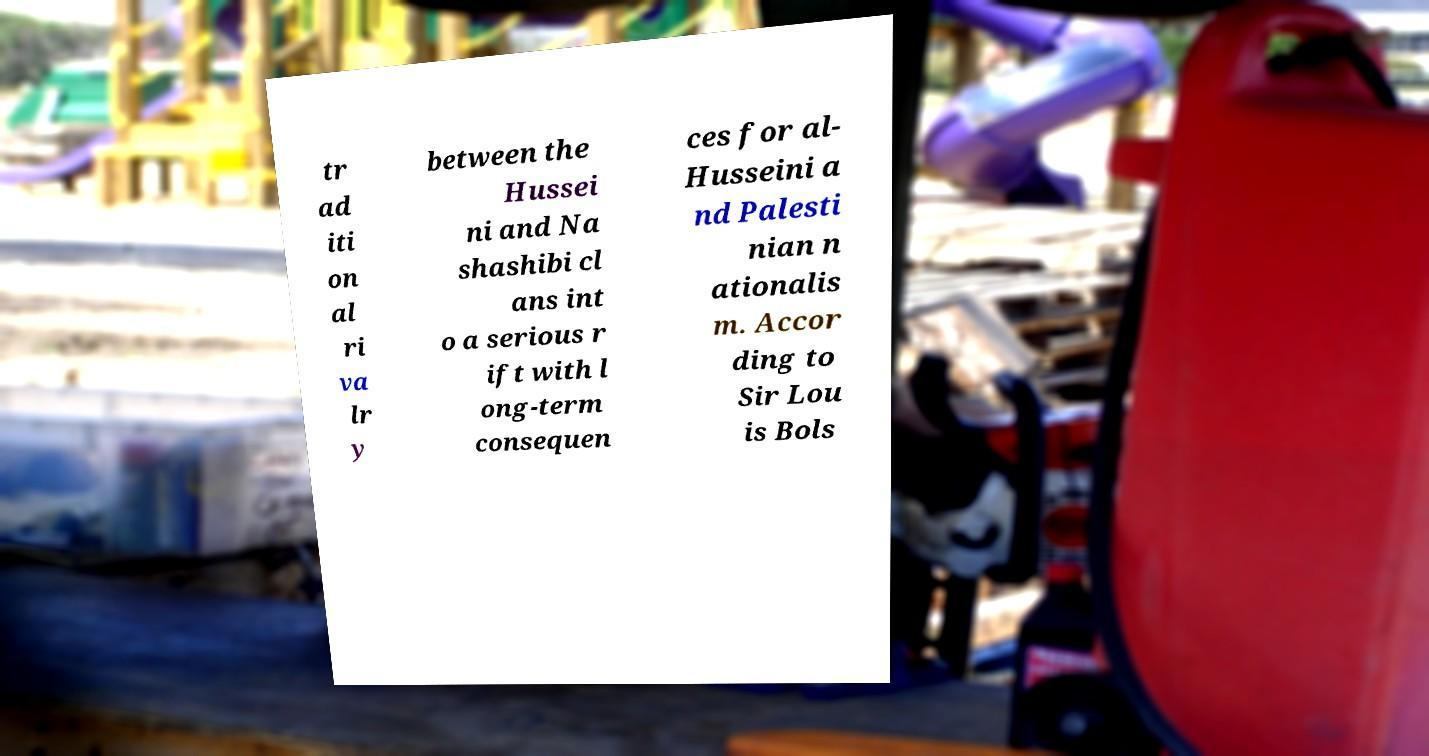There's text embedded in this image that I need extracted. Can you transcribe it verbatim? tr ad iti on al ri va lr y between the Hussei ni and Na shashibi cl ans int o a serious r ift with l ong-term consequen ces for al- Husseini a nd Palesti nian n ationalis m. Accor ding to Sir Lou is Bols 